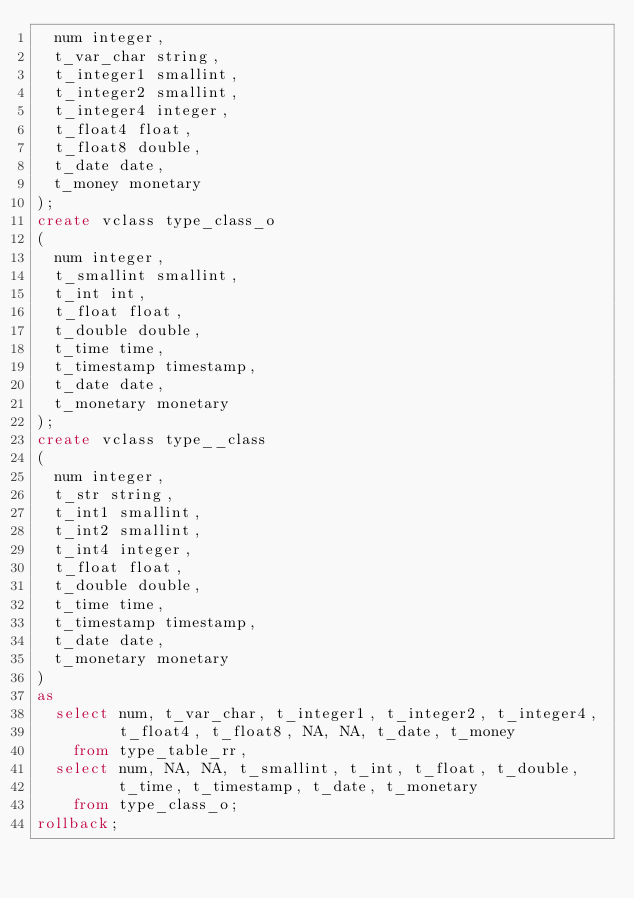<code> <loc_0><loc_0><loc_500><loc_500><_SQL_>  num integer,
  t_var_char string,
  t_integer1 smallint,
  t_integer2 smallint,
  t_integer4 integer,
  t_float4 float,
  t_float8 double,
  t_date date,
  t_money monetary
);
create vclass type_class_o
(
  num integer,
  t_smallint smallint,
  t_int int,
  t_float float,
  t_double double,
  t_time time,
  t_timestamp timestamp,
  t_date date,
  t_monetary monetary
);
create vclass type__class
(
  num integer,
  t_str string,
  t_int1 smallint,
  t_int2 smallint,
  t_int4 integer,
  t_float float,
  t_double double,
  t_time time,
  t_timestamp timestamp,
  t_date date,
  t_monetary monetary
)
as
  select num, t_var_char, t_integer1, t_integer2, t_integer4,
         t_float4, t_float8, NA, NA, t_date, t_money
    from type_table_rr,
  select num, NA, NA, t_smallint, t_int, t_float, t_double,
         t_time, t_timestamp, t_date, t_monetary
    from type_class_o;
rollback;
</code> 